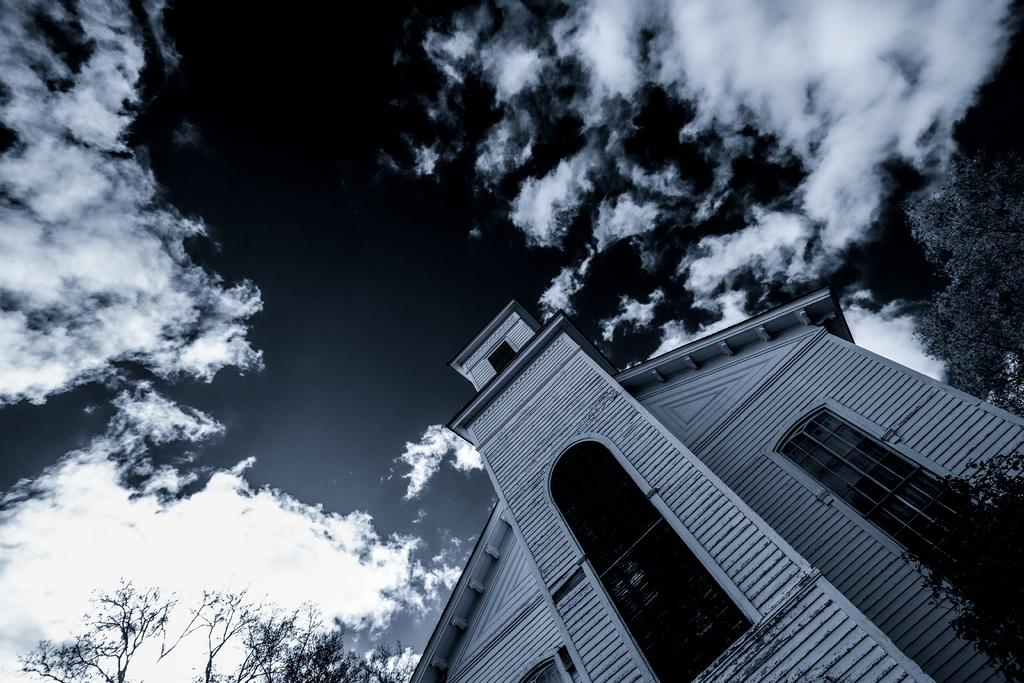What is the color scheme of the image? The image is black and white. What type of house can be seen in the image? There is a wooden house in the image. What other natural elements are present in the image? There are trees in the image. What can be seen in the background of the image? The sky is visible in the background of the image. What is the condition of the sky in the sky in the image? Clouds are present in the sky. Can you see a fish swimming in the sky in the image? No, there are no fish present in the image, and the sky is visible in the background, not the foreground. 